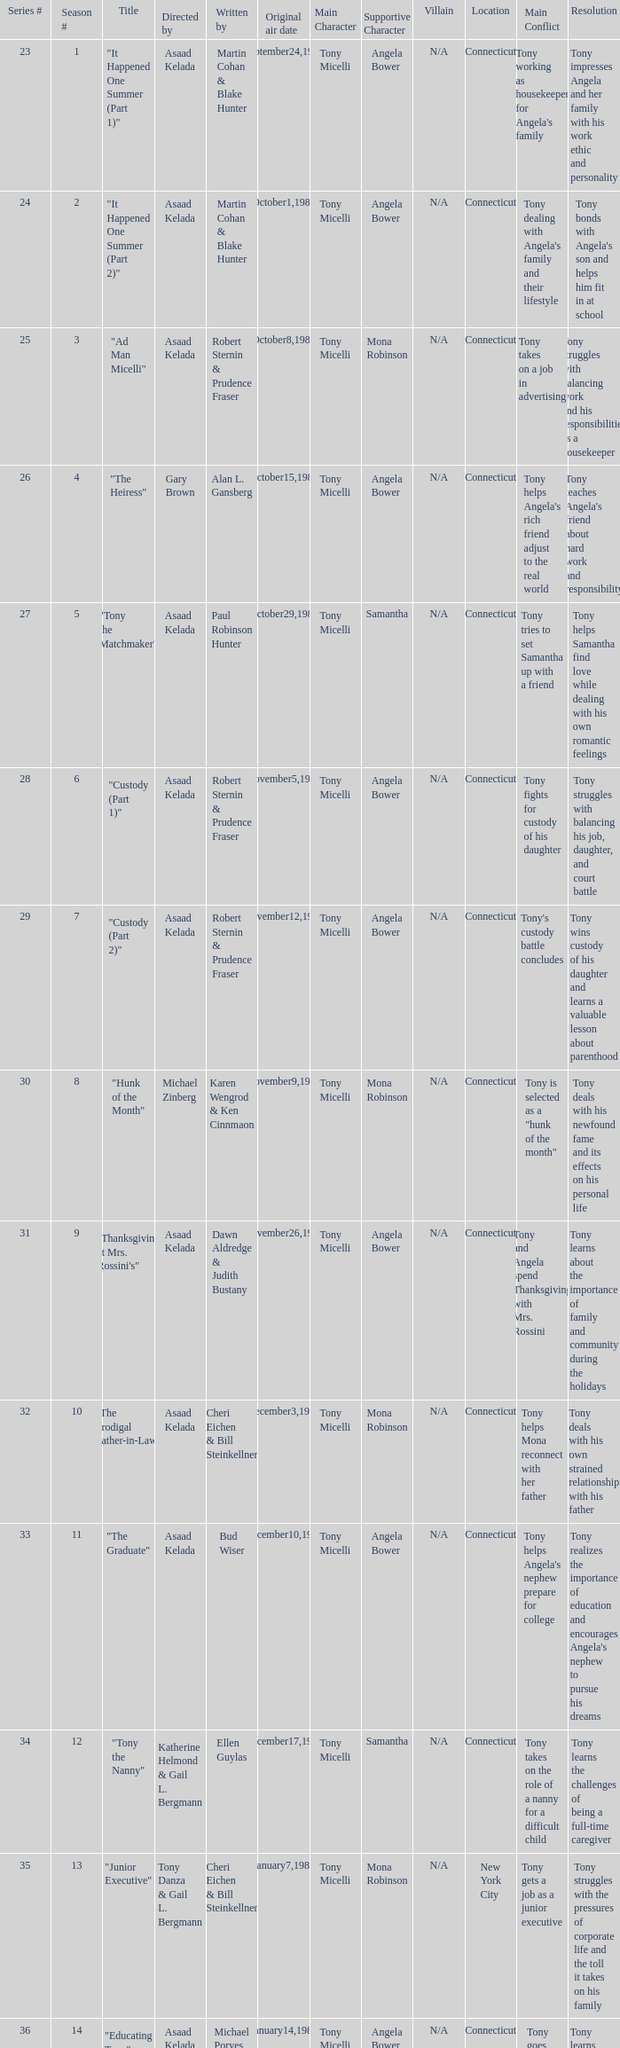What season features writer Michael Poryes? 14.0. 